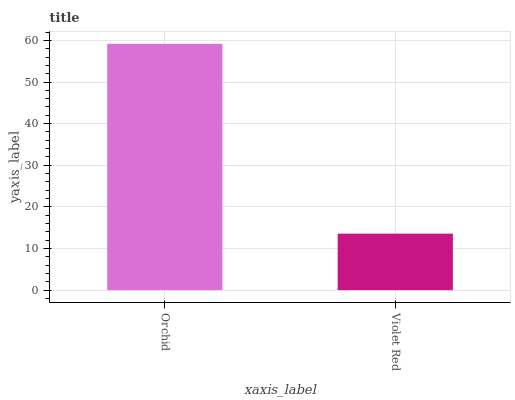Is Violet Red the minimum?
Answer yes or no. Yes. Is Orchid the maximum?
Answer yes or no. Yes. Is Violet Red the maximum?
Answer yes or no. No. Is Orchid greater than Violet Red?
Answer yes or no. Yes. Is Violet Red less than Orchid?
Answer yes or no. Yes. Is Violet Red greater than Orchid?
Answer yes or no. No. Is Orchid less than Violet Red?
Answer yes or no. No. Is Orchid the high median?
Answer yes or no. Yes. Is Violet Red the low median?
Answer yes or no. Yes. Is Violet Red the high median?
Answer yes or no. No. Is Orchid the low median?
Answer yes or no. No. 